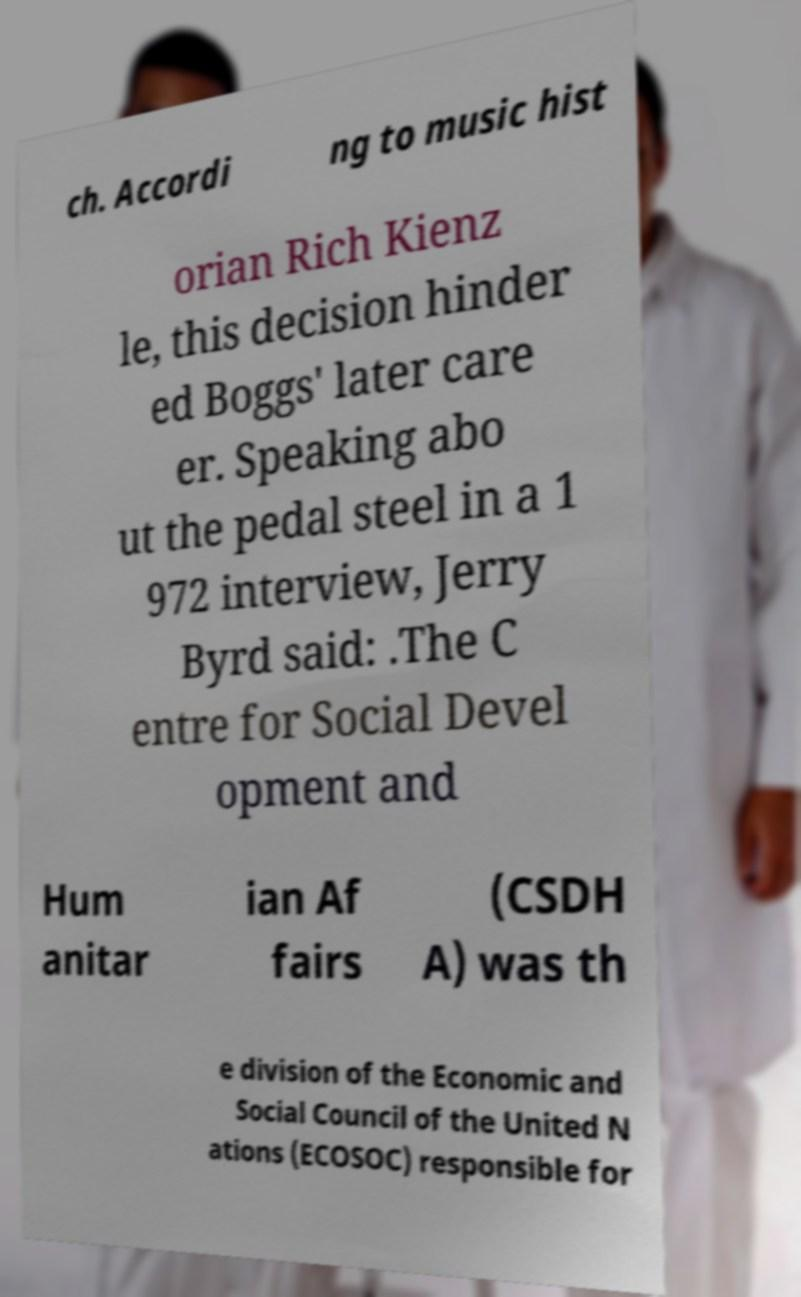Could you assist in decoding the text presented in this image and type it out clearly? ch. Accordi ng to music hist orian Rich Kienz le, this decision hinder ed Boggs' later care er. Speaking abo ut the pedal steel in a 1 972 interview, Jerry Byrd said: .The C entre for Social Devel opment and Hum anitar ian Af fairs (CSDH A) was th e division of the Economic and Social Council of the United N ations (ECOSOC) responsible for 